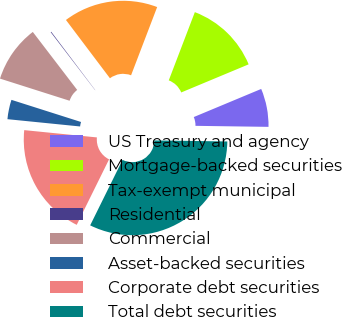Convert chart to OTSL. <chart><loc_0><loc_0><loc_500><loc_500><pie_chart><fcel>US Treasury and agency<fcel>Mortgage-backed securities<fcel>Tax-exempt municipal<fcel>Residential<fcel>Commercial<fcel>Asset-backed securities<fcel>Corporate debt securities<fcel>Total debt securities<nl><fcel>6.51%<fcel>12.9%<fcel>16.1%<fcel>0.11%<fcel>9.7%<fcel>3.31%<fcel>19.29%<fcel>32.08%<nl></chart> 